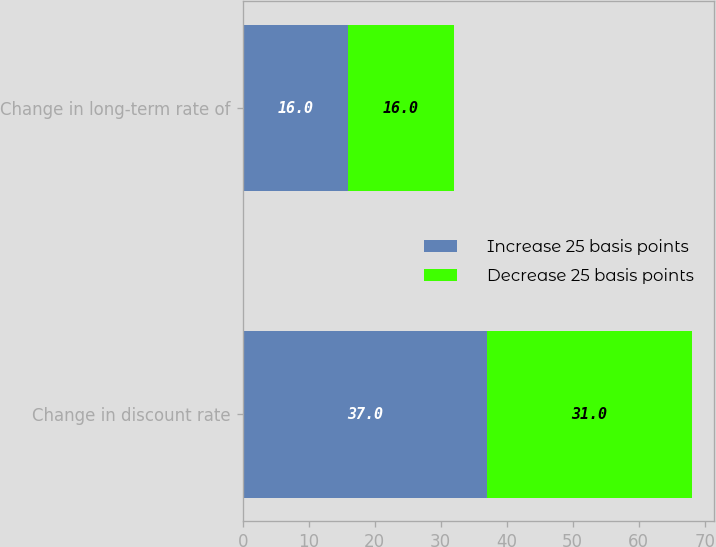<chart> <loc_0><loc_0><loc_500><loc_500><stacked_bar_chart><ecel><fcel>Change in discount rate<fcel>Change in long-term rate of<nl><fcel>Increase 25 basis points<fcel>37<fcel>16<nl><fcel>Decrease 25 basis points<fcel>31<fcel>16<nl></chart> 